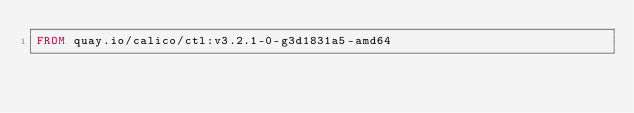<code> <loc_0><loc_0><loc_500><loc_500><_Dockerfile_>FROM quay.io/calico/ctl:v3.2.1-0-g3d1831a5-amd64
</code> 